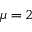<formula> <loc_0><loc_0><loc_500><loc_500>\mu = 2</formula> 